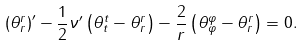Convert formula to latex. <formula><loc_0><loc_0><loc_500><loc_500>\left ( \theta ^ { r } _ { r } \right ) ^ { \prime } - \frac { 1 } { 2 } \nu ^ { \prime } \left ( \theta ^ { t } _ { t } - \theta ^ { r } _ { r } \right ) - \frac { 2 } { r } \left ( \theta ^ { \varphi } _ { \varphi } - \theta ^ { r } _ { r } \right ) = 0 .</formula> 